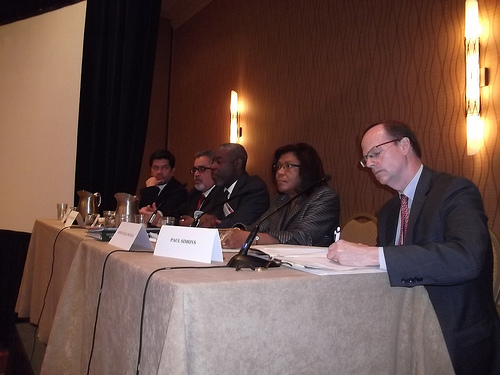<image>
Can you confirm if the pen is on the table? Yes. Looking at the image, I can see the pen is positioned on top of the table, with the table providing support. 